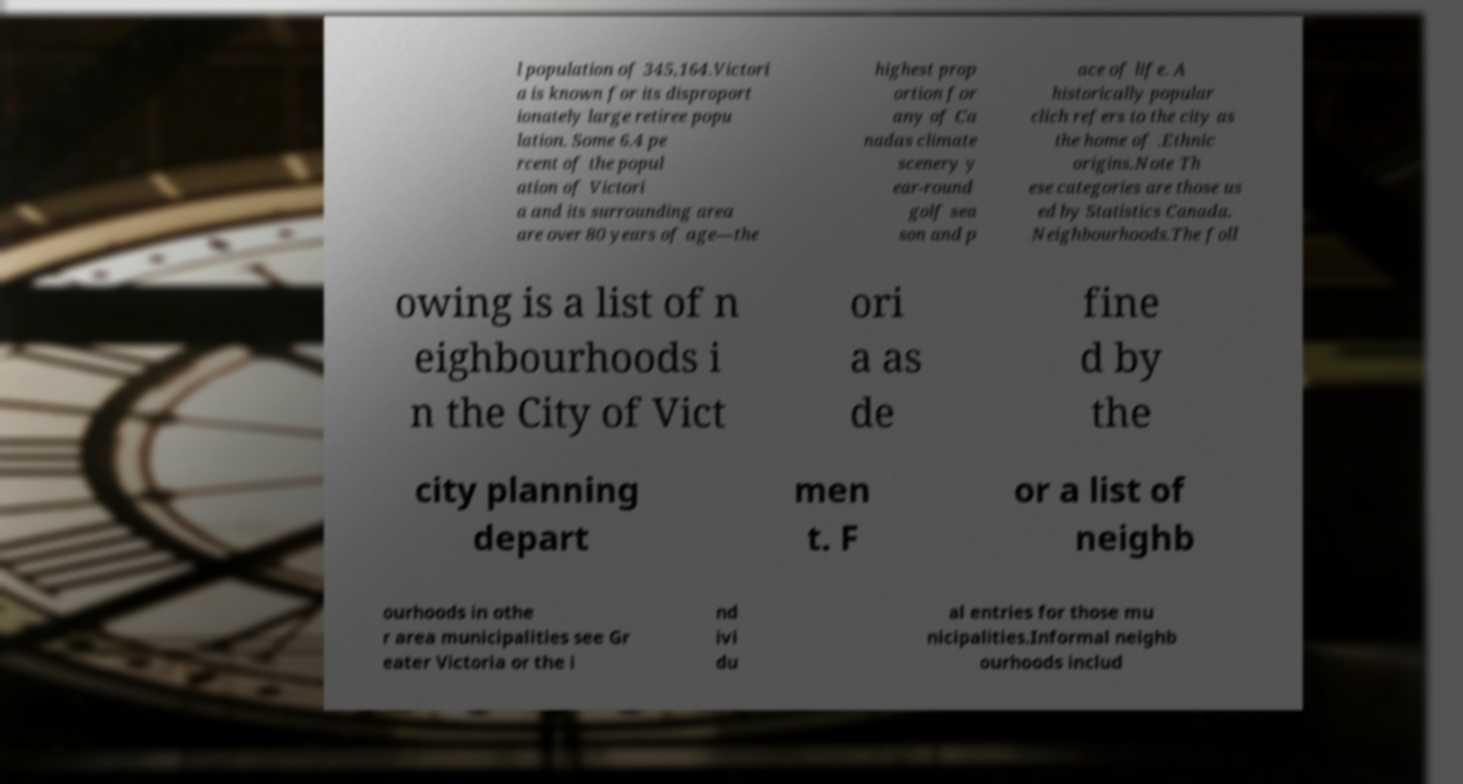Please read and relay the text visible in this image. What does it say? l population of 345,164.Victori a is known for its disproport ionately large retiree popu lation. Some 6.4 pe rcent of the popul ation of Victori a and its surrounding area are over 80 years of age—the highest prop ortion for any of Ca nadas climate scenery y ear-round golf sea son and p ace of life. A historically popular clich refers to the city as the home of .Ethnic origins.Note Th ese categories are those us ed by Statistics Canada. Neighbourhoods.The foll owing is a list of n eighbourhoods i n the City of Vict ori a as de fine d by the city planning depart men t. F or a list of neighb ourhoods in othe r area municipalities see Gr eater Victoria or the i nd ivi du al entries for those mu nicipalities.Informal neighb ourhoods includ 